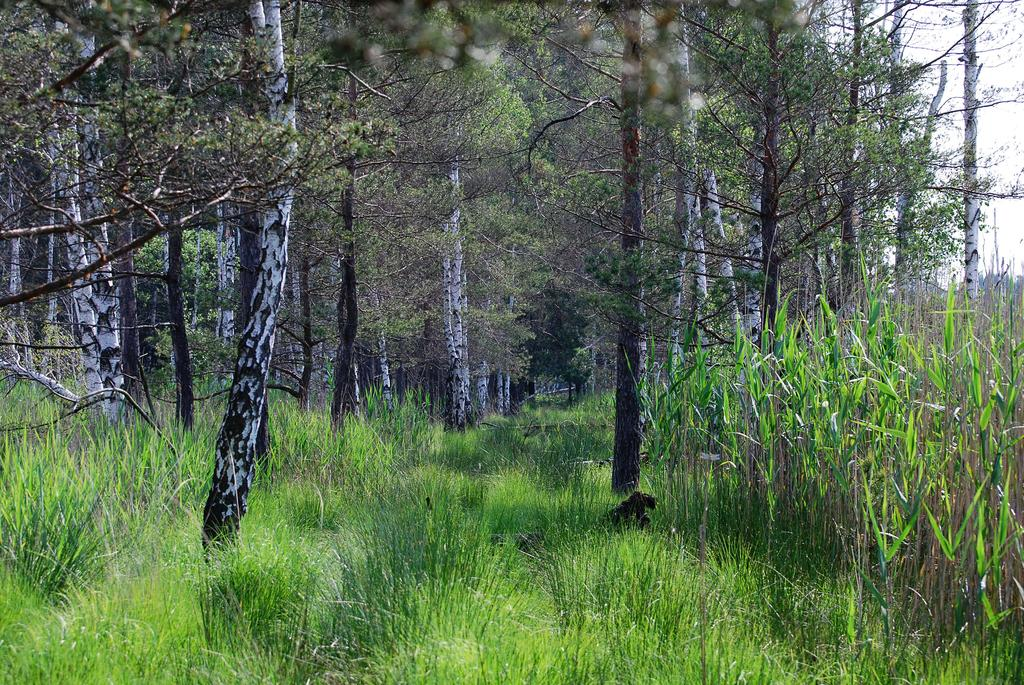What is visible in the background of the image? The sky is visible in the image. What can be seen in the sky? Clouds are present in the image. What type of vegetation is in the image? Trees and plants are in the image. What is the ground covered with in the image? Grass is visible in the image. Can you tell me how many passengers are sitting on the grass in the image? There are no passengers present in the image; it only features the sky, clouds, trees, plants, and grass. What type of fireman is visible in the image? There is no fireman present in the image. 